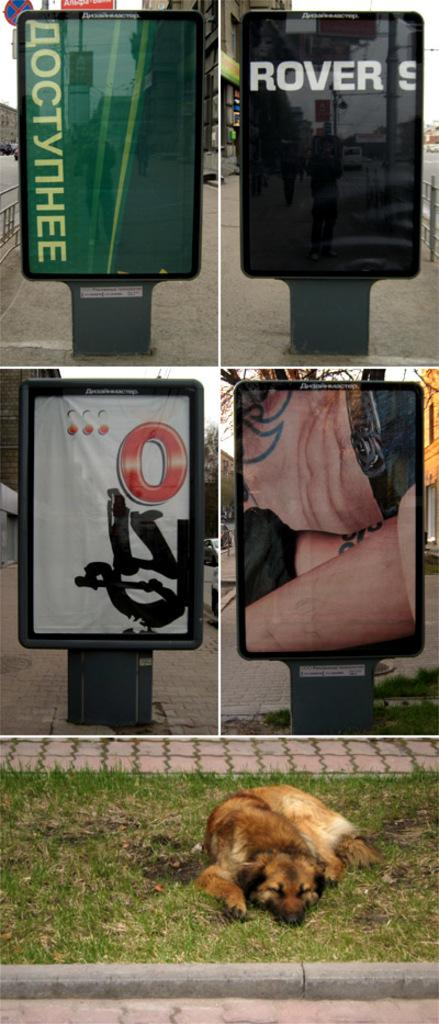What type of artwork is the image? The image is a collage. What can be seen on the boards in the image? The provided facts do not specify what is on the boards. What is the dog doing in the image? The dog is sleeping on the grass in the image. What can be seen in the distance in the image? Buildings, trees, and a fence are visible in the background of the image. Are there any other objects visible in the background of the image? Yes, there are other objects visible in the background of the image. What language is the cat speaking in the image? There is no cat present in the image, so it is not possible to determine what language it might be speaking. 